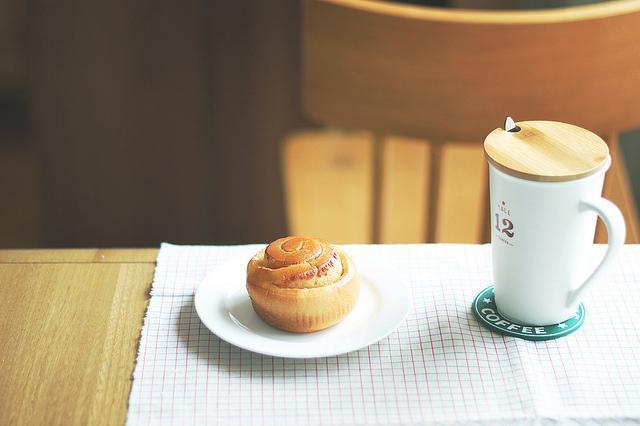Is this affirmation: "The cake is at the edge of the dining table." correct?
Answer yes or no. Yes. 